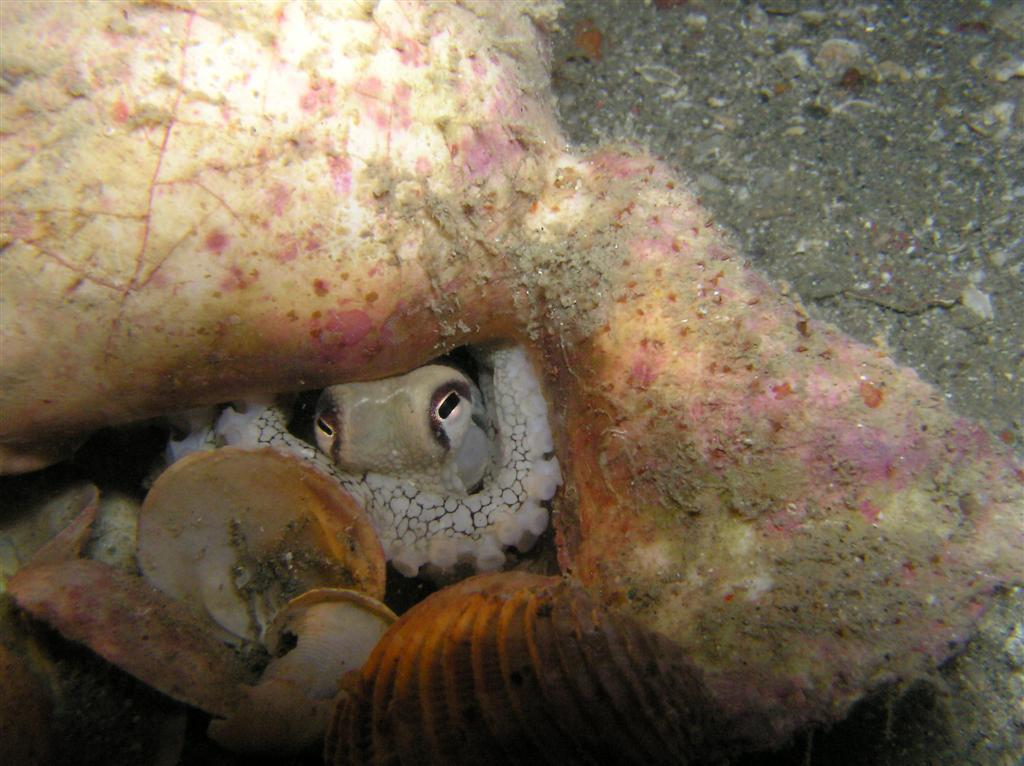What type of environment is shown in the image? The image depicts an underwater environment. What can be found at the bottom of the image? There are shells present at the bottom of the image. How many houses are visible in the image? There are no houses present in the image, as it depicts an underwater environment. What month is it in the image? The image does not provide any information about the month or time of year. 